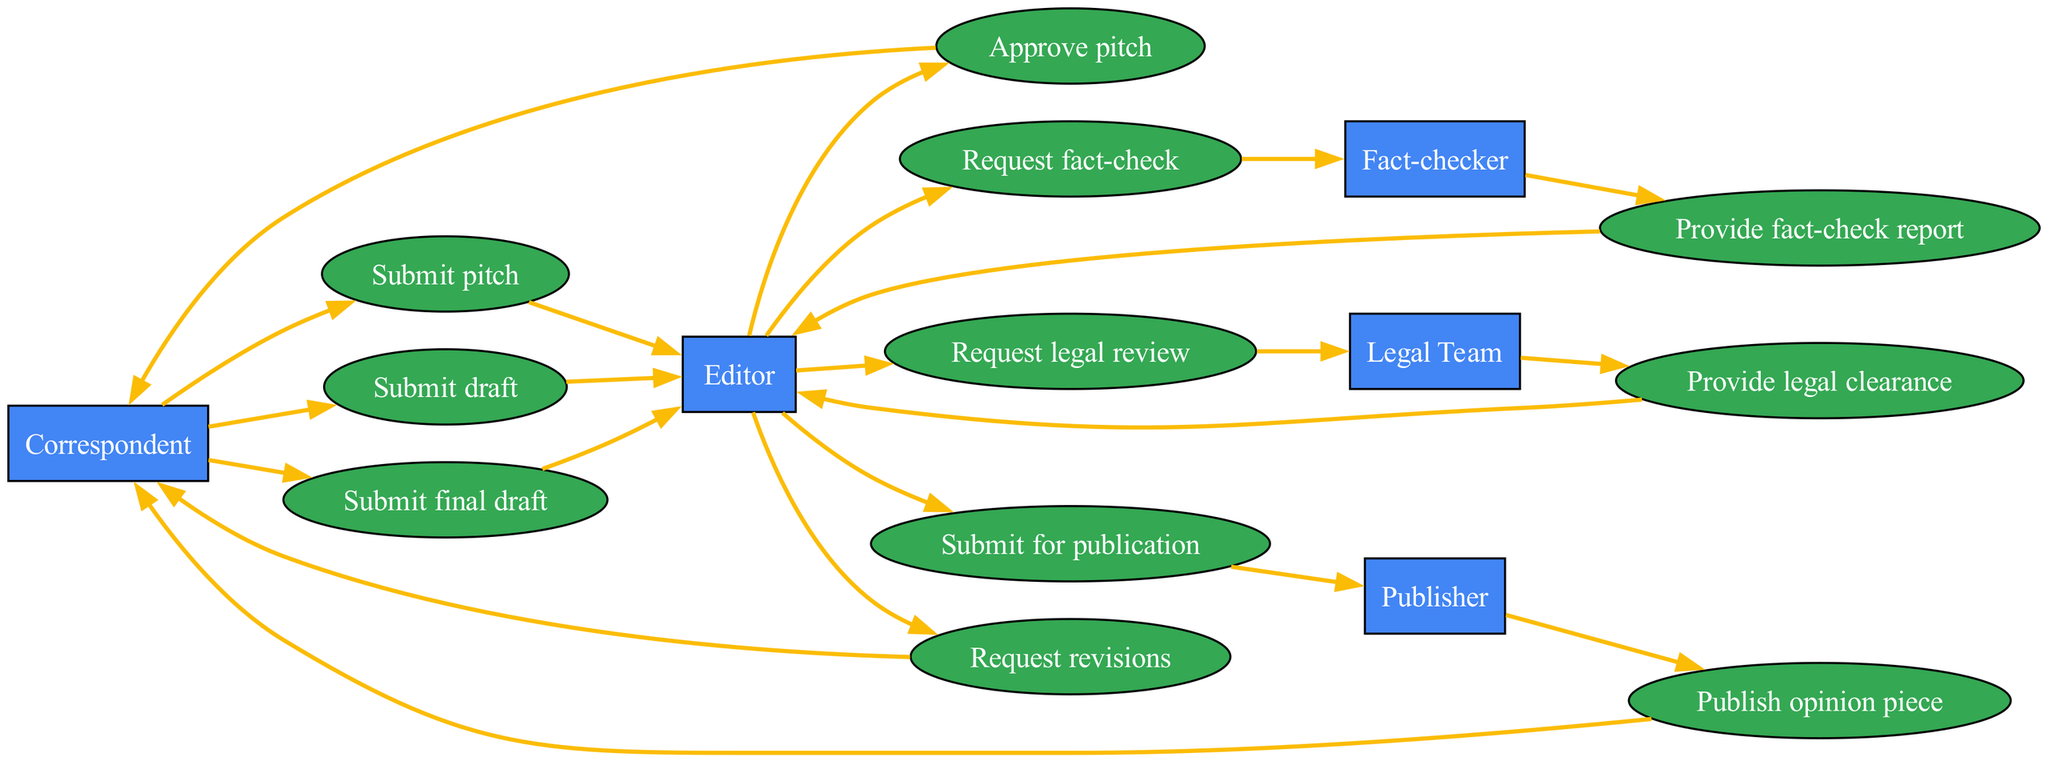What is the first action taken by the Correspondent? The first action is "Submit pitch," which is indicated as the initial step in the sequence where the Correspondent interacts with the Editor.
Answer: Submit pitch How many actors are involved in the sequence? The diagram lists five distinct actors: Correspondent, Editor, Fact-checker, Legal Team, and Publisher. By counting them, we confirm a total of five actors.
Answer: 5 What is the last action performed in the sequence? The last action is "Publish opinion piece," which occurs after the Publisher receives the final input from the Editor. This is clearly marked as the terminal action in the flow.
Answer: Publish opinion piece Which actor requests revisions? The Editor is shown as the actor who requests revisions from the Correspondent after reviewing the draft and feedback from the Fact-checker and Legal Team.
Answer: Editor After what action does the Legal Team provide a legal clearance? The Legal Team provides legal clearance after the Editor requests a legal review. This relationship is observed in the flow where the request precedes the provision of clearance.
Answer: Request legal review What is the relationship between the Editor and the Fact-checker? The relationship is that the Editor requests a fact-check from the Fact-checker, which indicates a reliance on the Fact-checker's expertise to validate the draft.
Answer: Request fact-check How many actions occur between the Correspondent and the Editor? There are four actions: the Correspondent submits a pitch, the Correspondent submits a draft, the Editor requests revisions, and the Correspondent submits a final draft. Counting these steps reveals the interactions.
Answer: 4 Which actor interacts directly with the Publisher? The Editor interacts directly with the Publisher by submitting the final piece for publication, as clearly indicated in the final steps of the sequence flow.
Answer: Editor What step follows the fact-check report? The next step after the fact-check report is the request for a legal review by the Editor, showing the sequences' logical progression from fact-checking to legal oversight.
Answer: Request legal review 